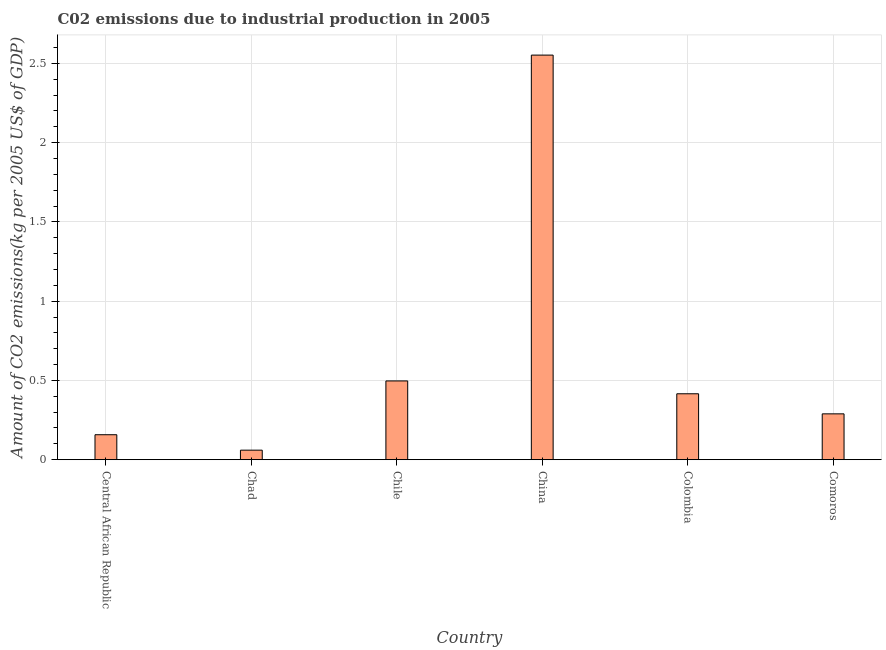Does the graph contain any zero values?
Make the answer very short. No. What is the title of the graph?
Your answer should be compact. C02 emissions due to industrial production in 2005. What is the label or title of the X-axis?
Your answer should be very brief. Country. What is the label or title of the Y-axis?
Your answer should be compact. Amount of CO2 emissions(kg per 2005 US$ of GDP). What is the amount of co2 emissions in China?
Your response must be concise. 2.55. Across all countries, what is the maximum amount of co2 emissions?
Provide a succinct answer. 2.55. Across all countries, what is the minimum amount of co2 emissions?
Give a very brief answer. 0.06. In which country was the amount of co2 emissions minimum?
Ensure brevity in your answer.  Chad. What is the sum of the amount of co2 emissions?
Your answer should be compact. 3.97. What is the difference between the amount of co2 emissions in Chad and Chile?
Provide a succinct answer. -0.44. What is the average amount of co2 emissions per country?
Ensure brevity in your answer.  0.66. What is the median amount of co2 emissions?
Your answer should be very brief. 0.35. In how many countries, is the amount of co2 emissions greater than 1.9 kg per 2005 US$ of GDP?
Provide a short and direct response. 1. What is the ratio of the amount of co2 emissions in Chile to that in Colombia?
Ensure brevity in your answer.  1.2. Is the amount of co2 emissions in Chile less than that in Comoros?
Offer a terse response. No. Is the difference between the amount of co2 emissions in China and Comoros greater than the difference between any two countries?
Provide a short and direct response. No. What is the difference between the highest and the second highest amount of co2 emissions?
Your response must be concise. 2.06. What is the difference between the highest and the lowest amount of co2 emissions?
Provide a succinct answer. 2.49. Are the values on the major ticks of Y-axis written in scientific E-notation?
Your answer should be very brief. No. What is the Amount of CO2 emissions(kg per 2005 US$ of GDP) of Central African Republic?
Provide a short and direct response. 0.16. What is the Amount of CO2 emissions(kg per 2005 US$ of GDP) in Chad?
Ensure brevity in your answer.  0.06. What is the Amount of CO2 emissions(kg per 2005 US$ of GDP) of Chile?
Your response must be concise. 0.5. What is the Amount of CO2 emissions(kg per 2005 US$ of GDP) of China?
Offer a very short reply. 2.55. What is the Amount of CO2 emissions(kg per 2005 US$ of GDP) of Colombia?
Provide a succinct answer. 0.42. What is the Amount of CO2 emissions(kg per 2005 US$ of GDP) of Comoros?
Your answer should be compact. 0.29. What is the difference between the Amount of CO2 emissions(kg per 2005 US$ of GDP) in Central African Republic and Chad?
Your answer should be very brief. 0.1. What is the difference between the Amount of CO2 emissions(kg per 2005 US$ of GDP) in Central African Republic and Chile?
Give a very brief answer. -0.34. What is the difference between the Amount of CO2 emissions(kg per 2005 US$ of GDP) in Central African Republic and China?
Ensure brevity in your answer.  -2.39. What is the difference between the Amount of CO2 emissions(kg per 2005 US$ of GDP) in Central African Republic and Colombia?
Offer a terse response. -0.26. What is the difference between the Amount of CO2 emissions(kg per 2005 US$ of GDP) in Central African Republic and Comoros?
Give a very brief answer. -0.13. What is the difference between the Amount of CO2 emissions(kg per 2005 US$ of GDP) in Chad and Chile?
Provide a succinct answer. -0.44. What is the difference between the Amount of CO2 emissions(kg per 2005 US$ of GDP) in Chad and China?
Provide a succinct answer. -2.49. What is the difference between the Amount of CO2 emissions(kg per 2005 US$ of GDP) in Chad and Colombia?
Ensure brevity in your answer.  -0.36. What is the difference between the Amount of CO2 emissions(kg per 2005 US$ of GDP) in Chad and Comoros?
Provide a succinct answer. -0.23. What is the difference between the Amount of CO2 emissions(kg per 2005 US$ of GDP) in Chile and China?
Provide a short and direct response. -2.06. What is the difference between the Amount of CO2 emissions(kg per 2005 US$ of GDP) in Chile and Colombia?
Your answer should be very brief. 0.08. What is the difference between the Amount of CO2 emissions(kg per 2005 US$ of GDP) in Chile and Comoros?
Offer a very short reply. 0.21. What is the difference between the Amount of CO2 emissions(kg per 2005 US$ of GDP) in China and Colombia?
Your response must be concise. 2.14. What is the difference between the Amount of CO2 emissions(kg per 2005 US$ of GDP) in China and Comoros?
Provide a short and direct response. 2.26. What is the difference between the Amount of CO2 emissions(kg per 2005 US$ of GDP) in Colombia and Comoros?
Offer a very short reply. 0.13. What is the ratio of the Amount of CO2 emissions(kg per 2005 US$ of GDP) in Central African Republic to that in Chad?
Your response must be concise. 2.62. What is the ratio of the Amount of CO2 emissions(kg per 2005 US$ of GDP) in Central African Republic to that in Chile?
Your answer should be very brief. 0.32. What is the ratio of the Amount of CO2 emissions(kg per 2005 US$ of GDP) in Central African Republic to that in China?
Offer a very short reply. 0.06. What is the ratio of the Amount of CO2 emissions(kg per 2005 US$ of GDP) in Central African Republic to that in Colombia?
Make the answer very short. 0.38. What is the ratio of the Amount of CO2 emissions(kg per 2005 US$ of GDP) in Central African Republic to that in Comoros?
Make the answer very short. 0.55. What is the ratio of the Amount of CO2 emissions(kg per 2005 US$ of GDP) in Chad to that in Chile?
Provide a succinct answer. 0.12. What is the ratio of the Amount of CO2 emissions(kg per 2005 US$ of GDP) in Chad to that in China?
Offer a very short reply. 0.02. What is the ratio of the Amount of CO2 emissions(kg per 2005 US$ of GDP) in Chad to that in Colombia?
Your response must be concise. 0.14. What is the ratio of the Amount of CO2 emissions(kg per 2005 US$ of GDP) in Chad to that in Comoros?
Keep it short and to the point. 0.21. What is the ratio of the Amount of CO2 emissions(kg per 2005 US$ of GDP) in Chile to that in China?
Ensure brevity in your answer.  0.2. What is the ratio of the Amount of CO2 emissions(kg per 2005 US$ of GDP) in Chile to that in Colombia?
Make the answer very short. 1.2. What is the ratio of the Amount of CO2 emissions(kg per 2005 US$ of GDP) in Chile to that in Comoros?
Give a very brief answer. 1.72. What is the ratio of the Amount of CO2 emissions(kg per 2005 US$ of GDP) in China to that in Colombia?
Offer a very short reply. 6.14. What is the ratio of the Amount of CO2 emissions(kg per 2005 US$ of GDP) in China to that in Comoros?
Your answer should be very brief. 8.82. What is the ratio of the Amount of CO2 emissions(kg per 2005 US$ of GDP) in Colombia to that in Comoros?
Your answer should be very brief. 1.44. 